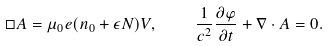Convert formula to latex. <formula><loc_0><loc_0><loc_500><loc_500>\Box { A } = \mu _ { 0 } e { \left ( n _ { 0 } + \epsilon N \right ) } { V } , \quad { \frac { 1 } { c ^ { 2 } } } { \frac { \partial \varphi } { \partial t } } + \nabla \cdot { A } = 0 .</formula> 